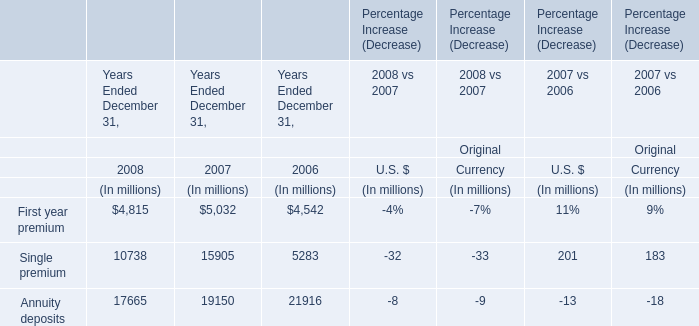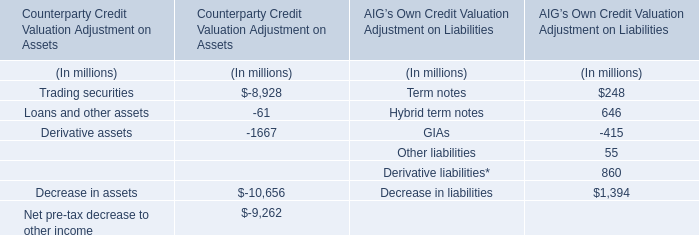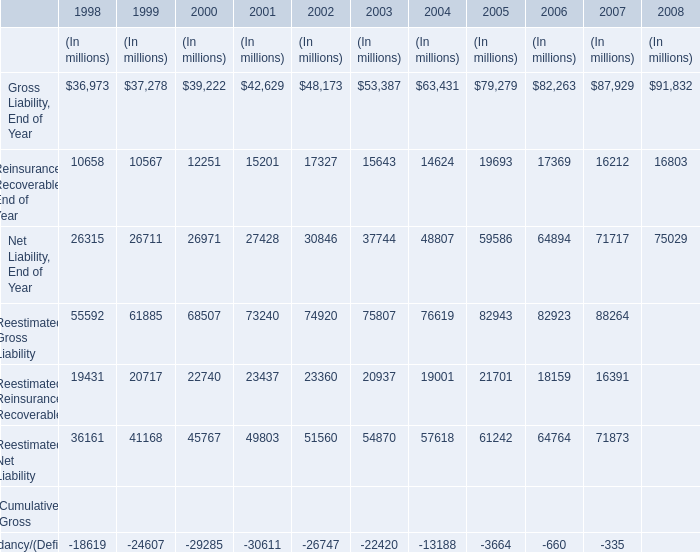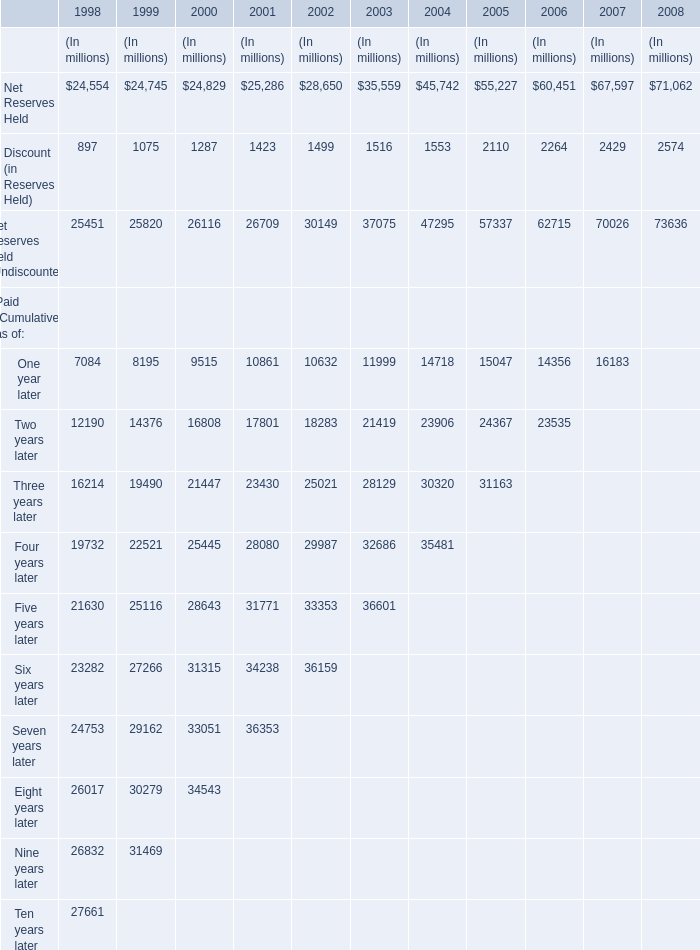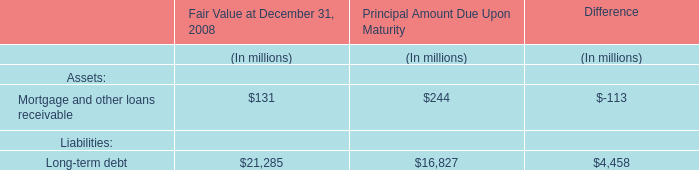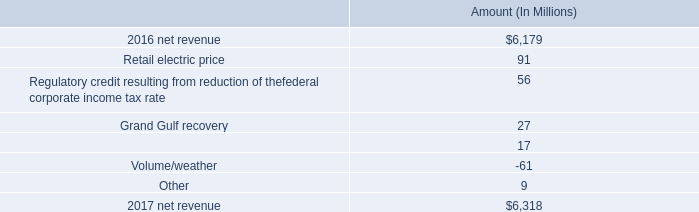What's the growth rate of Gross Liability, in 2008? 
Computations: ((91832 - 87929) / 87929)
Answer: 0.04439. 